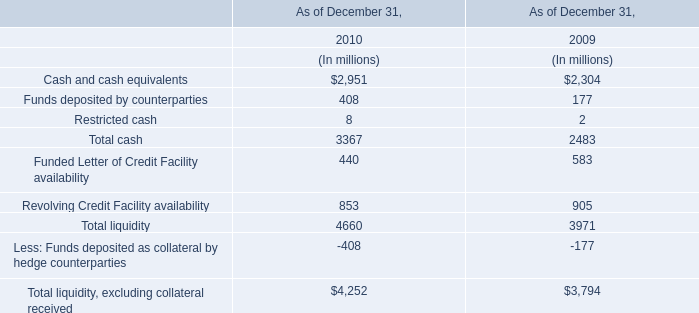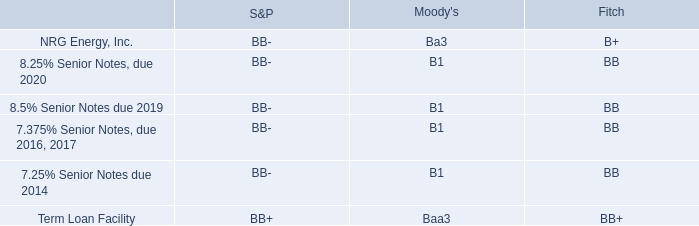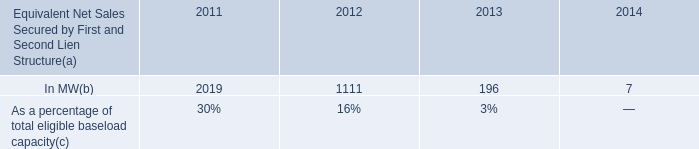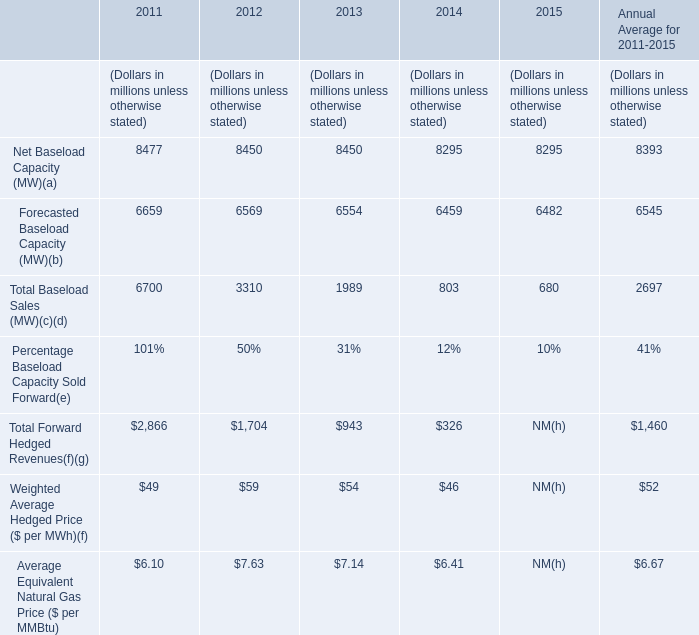What is the average value of Total Forward Hedged Revenues in 2012,2013 and 2014 ? 
Computations: (((1704 + 943) + 326) / 3)
Answer: 991.0. 